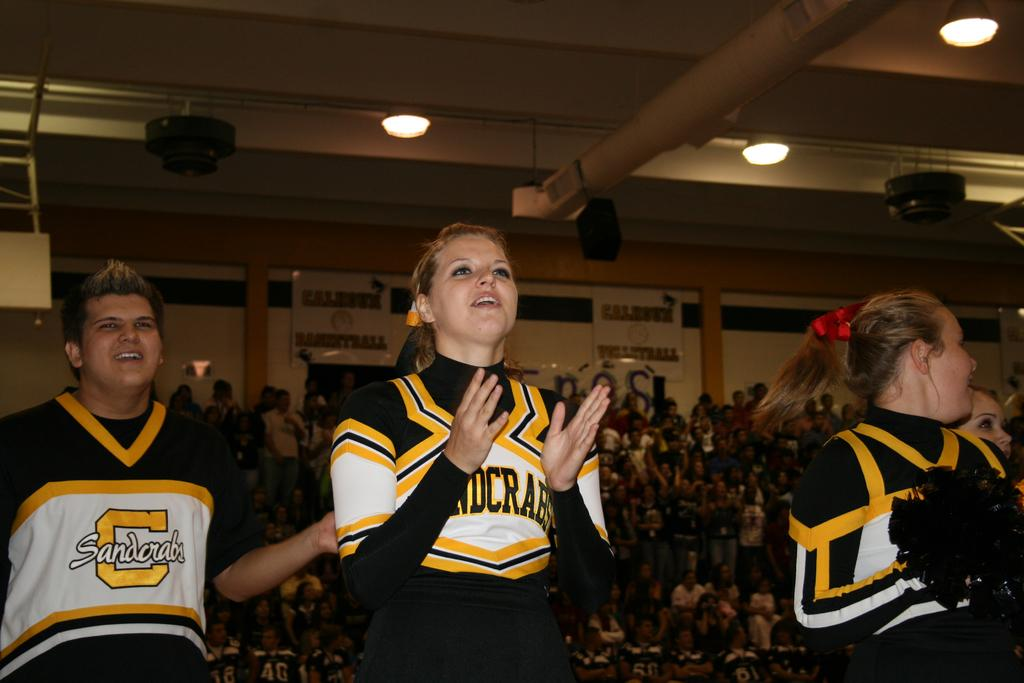<image>
Offer a succinct explanation of the picture presented. Cheerleaders for the Sandcrabs cheer in a gym full of people. 